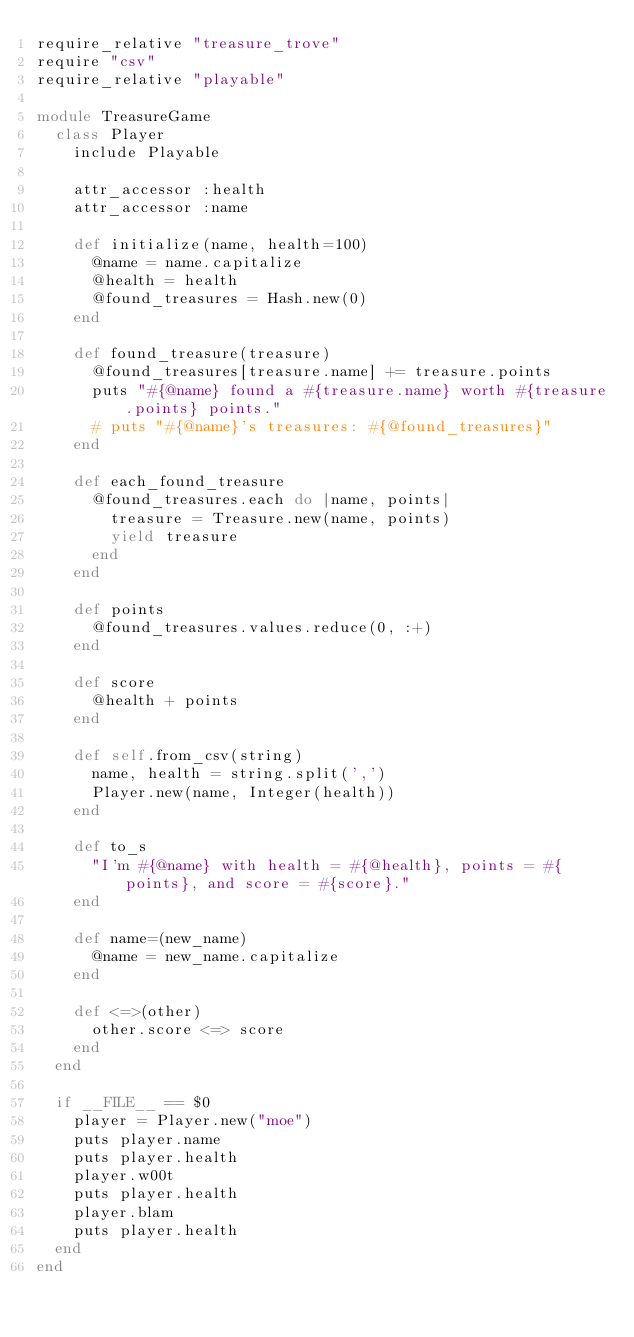Convert code to text. <code><loc_0><loc_0><loc_500><loc_500><_Ruby_>require_relative "treasure_trove"
require "csv"
require_relative "playable"

module TreasureGame
  class Player
    include Playable

    attr_accessor :health
    attr_accessor :name

    def initialize(name, health=100)
      @name = name.capitalize
      @health = health
      @found_treasures = Hash.new(0)
    end

    def found_treasure(treasure)
      @found_treasures[treasure.name] += treasure.points
      puts "#{@name} found a #{treasure.name} worth #{treasure.points} points."
      # puts "#{@name}'s treasures: #{@found_treasures}"
    end

    def each_found_treasure
      @found_treasures.each do |name, points|
        treasure = Treasure.new(name, points)
        yield treasure
      end
    end

    def points
      @found_treasures.values.reduce(0, :+)
    end

    def score
      @health + points
    end

    def self.from_csv(string)
      name, health = string.split(',')
      Player.new(name, Integer(health))
    end

    def to_s
      "I'm #{@name} with health = #{@health}, points = #{points}, and score = #{score}."
    end

    def name=(new_name)
      @name = new_name.capitalize
    end

    def <=>(other)
      other.score <=> score
    end
  end

  if __FILE__ == $0
    player = Player.new("moe")
    puts player.name
    puts player.health
    player.w00t
    puts player.health
    player.blam
    puts player.health
  end
end
</code> 